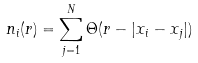Convert formula to latex. <formula><loc_0><loc_0><loc_500><loc_500>n _ { i } ( r ) = \sum _ { j = 1 } ^ { N } \Theta ( r - | x _ { i } - x _ { j } | )</formula> 